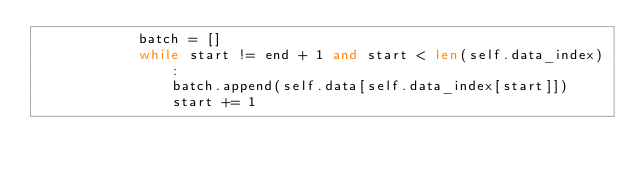<code> <loc_0><loc_0><loc_500><loc_500><_Python_>            batch = []
            while start != end + 1 and start < len(self.data_index):
                batch.append(self.data[self.data_index[start]])
                start += 1</code> 